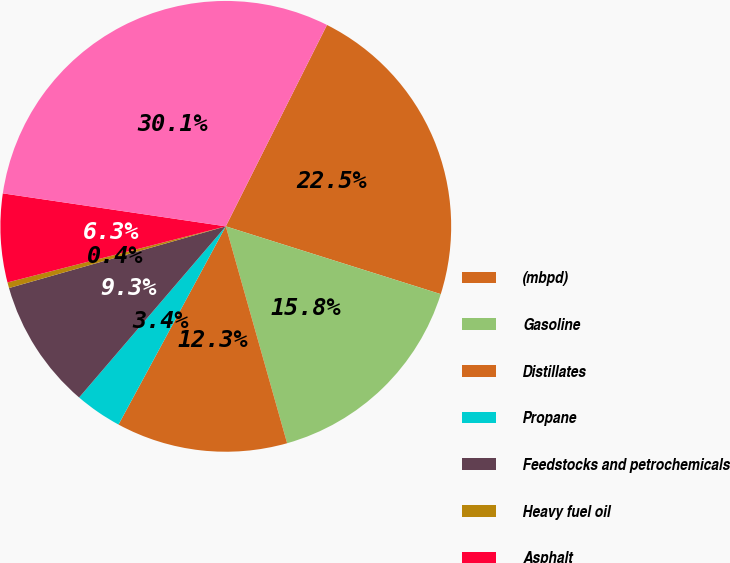<chart> <loc_0><loc_0><loc_500><loc_500><pie_chart><fcel>(mbpd)<fcel>Gasoline<fcel>Distillates<fcel>Propane<fcel>Feedstocks and petrochemicals<fcel>Heavy fuel oil<fcel>Asphalt<fcel>Total<nl><fcel>22.45%<fcel>15.75%<fcel>12.28%<fcel>3.38%<fcel>9.31%<fcel>0.41%<fcel>6.34%<fcel>30.07%<nl></chart> 